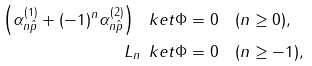<formula> <loc_0><loc_0><loc_500><loc_500>\left ( \alpha ^ { ( 1 ) } _ { n \hat { p } } + ( - 1 ) ^ { n } \alpha ^ { ( 2 ) } _ { n \hat { p } } \right ) \ k e t { \Phi } & = 0 \quad ( n \geq 0 ) , \\ L _ { n } \, \ k e t { \Phi } & = 0 \quad ( n \geq - 1 ) ,</formula> 